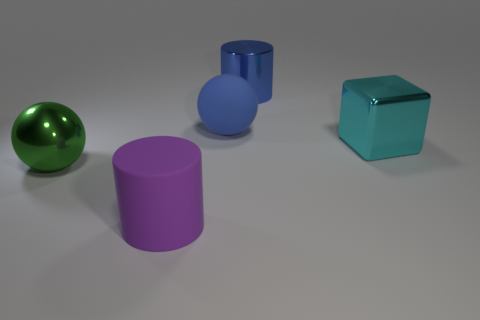What number of rubber objects are either big green spheres or tiny red cylinders?
Provide a short and direct response. 0. The large purple rubber object is what shape?
Your response must be concise. Cylinder. How many other large cyan blocks have the same material as the cyan cube?
Your answer should be compact. 0. The large cylinder that is made of the same material as the blue ball is what color?
Make the answer very short. Purple. Is the size of the cylinder that is in front of the cyan metal thing the same as the blue cylinder?
Give a very brief answer. Yes. There is another large matte thing that is the same shape as the green thing; what is its color?
Ensure brevity in your answer.  Blue. The rubber thing right of the large cylinder that is in front of the matte object that is behind the purple rubber object is what shape?
Provide a succinct answer. Sphere. Do the big green metallic thing and the big blue matte object have the same shape?
Your answer should be compact. Yes. There is a large blue thing in front of the large cylinder behind the metal sphere; what is its shape?
Your response must be concise. Sphere. Are any big blue rubber balls visible?
Your response must be concise. Yes. 